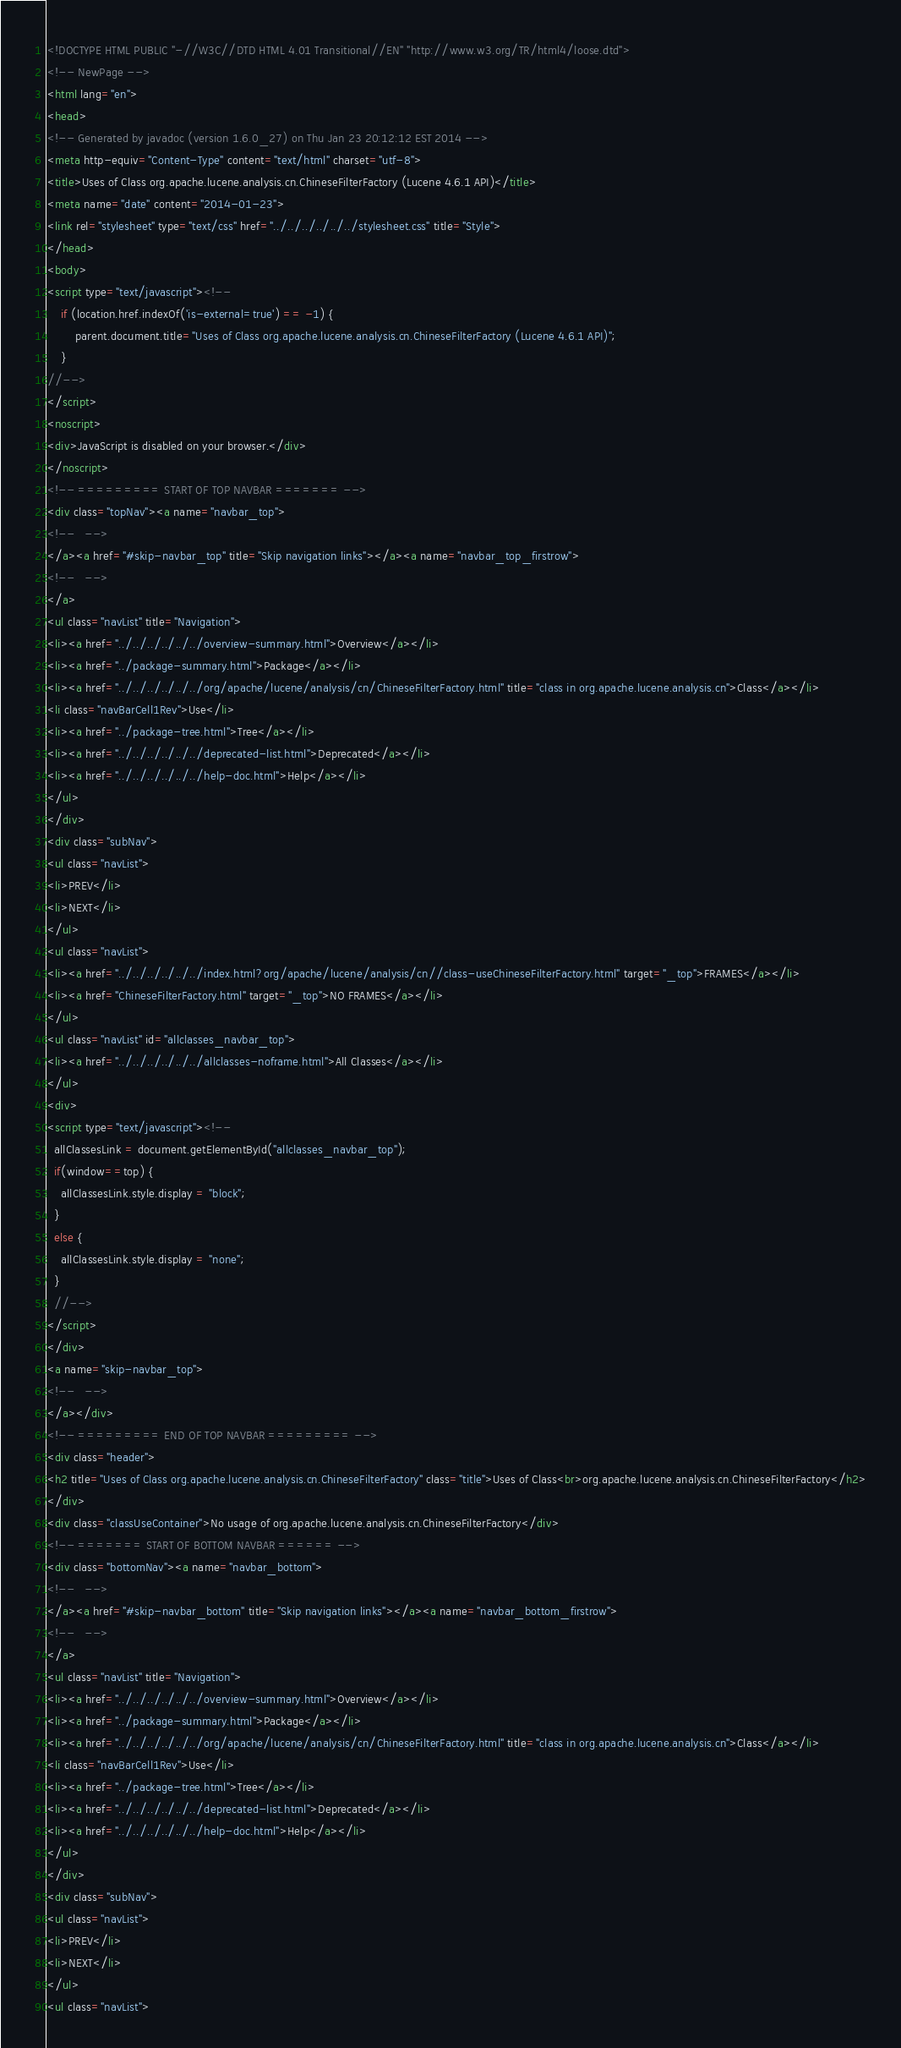Convert code to text. <code><loc_0><loc_0><loc_500><loc_500><_HTML_><!DOCTYPE HTML PUBLIC "-//W3C//DTD HTML 4.01 Transitional//EN" "http://www.w3.org/TR/html4/loose.dtd">
<!-- NewPage -->
<html lang="en">
<head>
<!-- Generated by javadoc (version 1.6.0_27) on Thu Jan 23 20:12:12 EST 2014 -->
<meta http-equiv="Content-Type" content="text/html" charset="utf-8">
<title>Uses of Class org.apache.lucene.analysis.cn.ChineseFilterFactory (Lucene 4.6.1 API)</title>
<meta name="date" content="2014-01-23">
<link rel="stylesheet" type="text/css" href="../../../../../../stylesheet.css" title="Style">
</head>
<body>
<script type="text/javascript"><!--
    if (location.href.indexOf('is-external=true') == -1) {
        parent.document.title="Uses of Class org.apache.lucene.analysis.cn.ChineseFilterFactory (Lucene 4.6.1 API)";
    }
//-->
</script>
<noscript>
<div>JavaScript is disabled on your browser.</div>
</noscript>
<!-- ========= START OF TOP NAVBAR ======= -->
<div class="topNav"><a name="navbar_top">
<!--   -->
</a><a href="#skip-navbar_top" title="Skip navigation links"></a><a name="navbar_top_firstrow">
<!--   -->
</a>
<ul class="navList" title="Navigation">
<li><a href="../../../../../../overview-summary.html">Overview</a></li>
<li><a href="../package-summary.html">Package</a></li>
<li><a href="../../../../../../org/apache/lucene/analysis/cn/ChineseFilterFactory.html" title="class in org.apache.lucene.analysis.cn">Class</a></li>
<li class="navBarCell1Rev">Use</li>
<li><a href="../package-tree.html">Tree</a></li>
<li><a href="../../../../../../deprecated-list.html">Deprecated</a></li>
<li><a href="../../../../../../help-doc.html">Help</a></li>
</ul>
</div>
<div class="subNav">
<ul class="navList">
<li>PREV</li>
<li>NEXT</li>
</ul>
<ul class="navList">
<li><a href="../../../../../../index.html?org/apache/lucene/analysis/cn//class-useChineseFilterFactory.html" target="_top">FRAMES</a></li>
<li><a href="ChineseFilterFactory.html" target="_top">NO FRAMES</a></li>
</ul>
<ul class="navList" id="allclasses_navbar_top">
<li><a href="../../../../../../allclasses-noframe.html">All Classes</a></li>
</ul>
<div>
<script type="text/javascript"><!--
  allClassesLink = document.getElementById("allclasses_navbar_top");
  if(window==top) {
    allClassesLink.style.display = "block";
  }
  else {
    allClassesLink.style.display = "none";
  }
  //-->
</script>
</div>
<a name="skip-navbar_top">
<!--   -->
</a></div>
<!-- ========= END OF TOP NAVBAR ========= -->
<div class="header">
<h2 title="Uses of Class org.apache.lucene.analysis.cn.ChineseFilterFactory" class="title">Uses of Class<br>org.apache.lucene.analysis.cn.ChineseFilterFactory</h2>
</div>
<div class="classUseContainer">No usage of org.apache.lucene.analysis.cn.ChineseFilterFactory</div>
<!-- ======= START OF BOTTOM NAVBAR ====== -->
<div class="bottomNav"><a name="navbar_bottom">
<!--   -->
</a><a href="#skip-navbar_bottom" title="Skip navigation links"></a><a name="navbar_bottom_firstrow">
<!--   -->
</a>
<ul class="navList" title="Navigation">
<li><a href="../../../../../../overview-summary.html">Overview</a></li>
<li><a href="../package-summary.html">Package</a></li>
<li><a href="../../../../../../org/apache/lucene/analysis/cn/ChineseFilterFactory.html" title="class in org.apache.lucene.analysis.cn">Class</a></li>
<li class="navBarCell1Rev">Use</li>
<li><a href="../package-tree.html">Tree</a></li>
<li><a href="../../../../../../deprecated-list.html">Deprecated</a></li>
<li><a href="../../../../../../help-doc.html">Help</a></li>
</ul>
</div>
<div class="subNav">
<ul class="navList">
<li>PREV</li>
<li>NEXT</li>
</ul>
<ul class="navList"></code> 